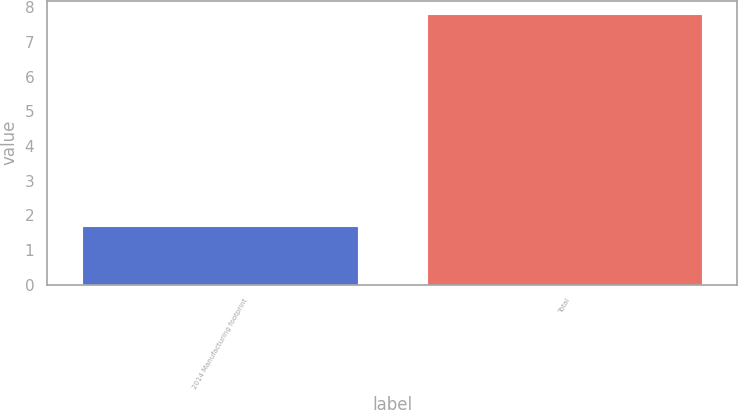<chart> <loc_0><loc_0><loc_500><loc_500><bar_chart><fcel>2014 Manufacturing footprint<fcel>Total<nl><fcel>1.7<fcel>7.8<nl></chart> 